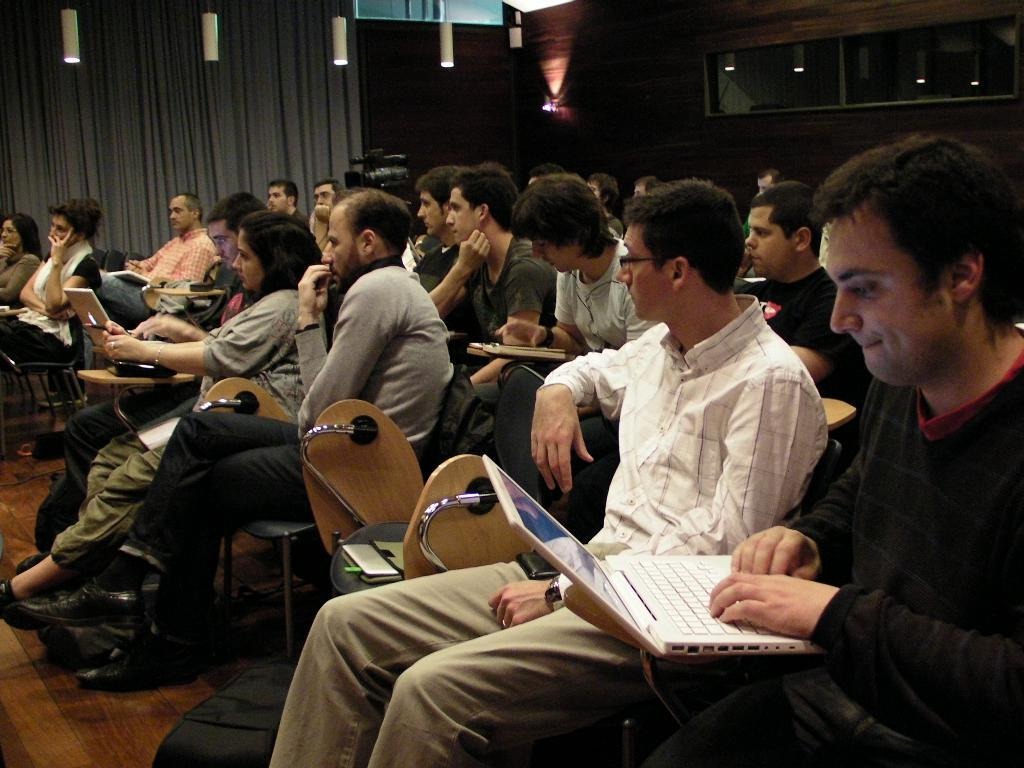What are the people in the image doing? The people in the image are sitting. What electronic devices can be seen in the image? There are laptops in the image. What items might the people be carrying or using? There are bags in the image. What can be seen in the background of the image? There is a curtain and a wall in the background of the image. What is providing illumination in the image? There are lights visible in the image. What type of plantation is visible in the image? There is no plantation present in the image. What class of students are shown in the image? The image does not depict a class or students. 